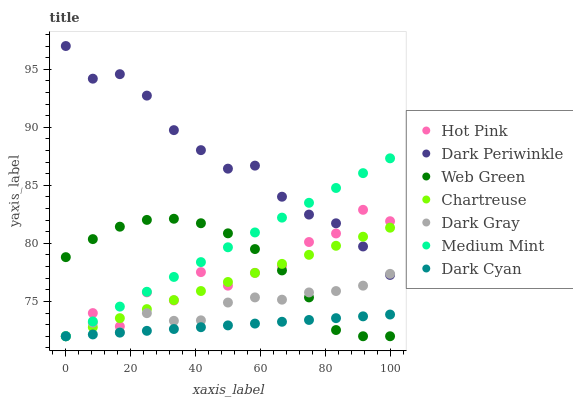Does Dark Cyan have the minimum area under the curve?
Answer yes or no. Yes. Does Dark Periwinkle have the maximum area under the curve?
Answer yes or no. Yes. Does Hot Pink have the minimum area under the curve?
Answer yes or no. No. Does Hot Pink have the maximum area under the curve?
Answer yes or no. No. Is Dark Cyan the smoothest?
Answer yes or no. Yes. Is Hot Pink the roughest?
Answer yes or no. Yes. Is Web Green the smoothest?
Answer yes or no. No. Is Web Green the roughest?
Answer yes or no. No. Does Medium Mint have the lowest value?
Answer yes or no. Yes. Does Dark Periwinkle have the lowest value?
Answer yes or no. No. Does Dark Periwinkle have the highest value?
Answer yes or no. Yes. Does Hot Pink have the highest value?
Answer yes or no. No. Is Web Green less than Dark Periwinkle?
Answer yes or no. Yes. Is Dark Periwinkle greater than Dark Cyan?
Answer yes or no. Yes. Does Hot Pink intersect Dark Periwinkle?
Answer yes or no. Yes. Is Hot Pink less than Dark Periwinkle?
Answer yes or no. No. Is Hot Pink greater than Dark Periwinkle?
Answer yes or no. No. Does Web Green intersect Dark Periwinkle?
Answer yes or no. No. 